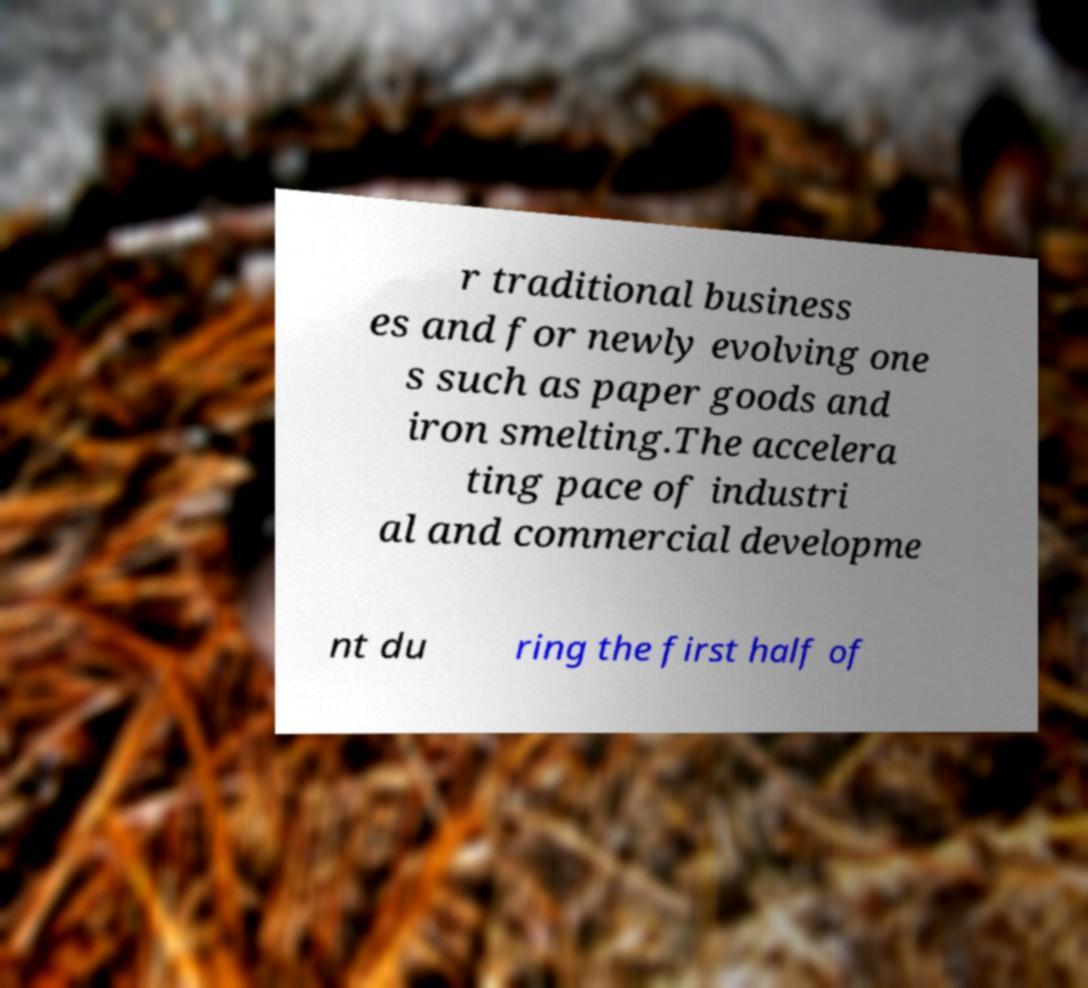What messages or text are displayed in this image? I need them in a readable, typed format. r traditional business es and for newly evolving one s such as paper goods and iron smelting.The accelera ting pace of industri al and commercial developme nt du ring the first half of 